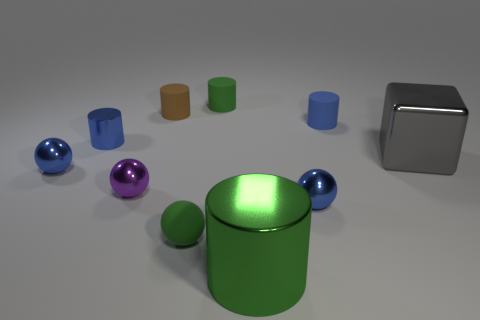Subtract all brown cylinders. How many cylinders are left? 4 Subtract all green rubber cylinders. How many cylinders are left? 4 Subtract all red balls. Subtract all gray cylinders. How many balls are left? 4 Subtract all balls. How many objects are left? 6 Add 8 large gray shiny things. How many large gray shiny things are left? 9 Add 5 big shiny cubes. How many big shiny cubes exist? 6 Subtract 0 brown spheres. How many objects are left? 10 Subtract all tiny green matte cylinders. Subtract all brown rubber cylinders. How many objects are left? 8 